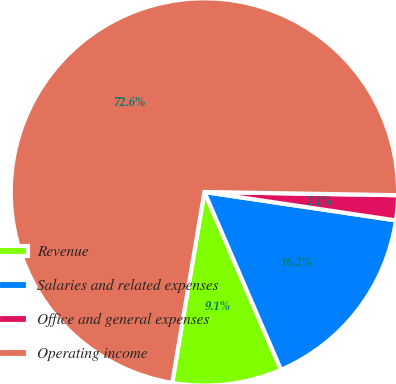Convert chart. <chart><loc_0><loc_0><loc_500><loc_500><pie_chart><fcel>Revenue<fcel>Salaries and related expenses<fcel>Office and general expenses<fcel>Operating income<nl><fcel>9.13%<fcel>16.18%<fcel>2.08%<fcel>72.6%<nl></chart> 